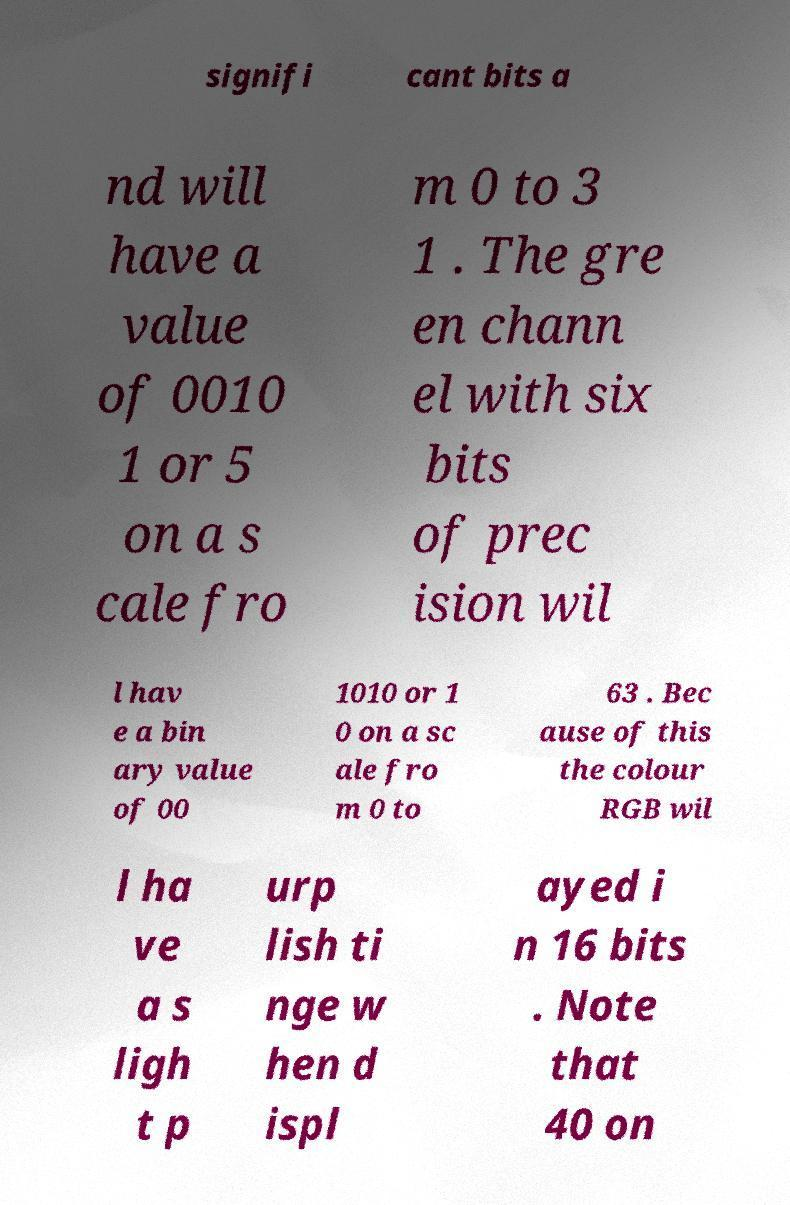What messages or text are displayed in this image? I need them in a readable, typed format. signifi cant bits a nd will have a value of 0010 1 or 5 on a s cale fro m 0 to 3 1 . The gre en chann el with six bits of prec ision wil l hav e a bin ary value of 00 1010 or 1 0 on a sc ale fro m 0 to 63 . Bec ause of this the colour RGB wil l ha ve a s ligh t p urp lish ti nge w hen d ispl ayed i n 16 bits . Note that 40 on 